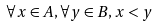Convert formula to latex. <formula><loc_0><loc_0><loc_500><loc_500>\forall x \in A , \forall y \in B , x < y</formula> 